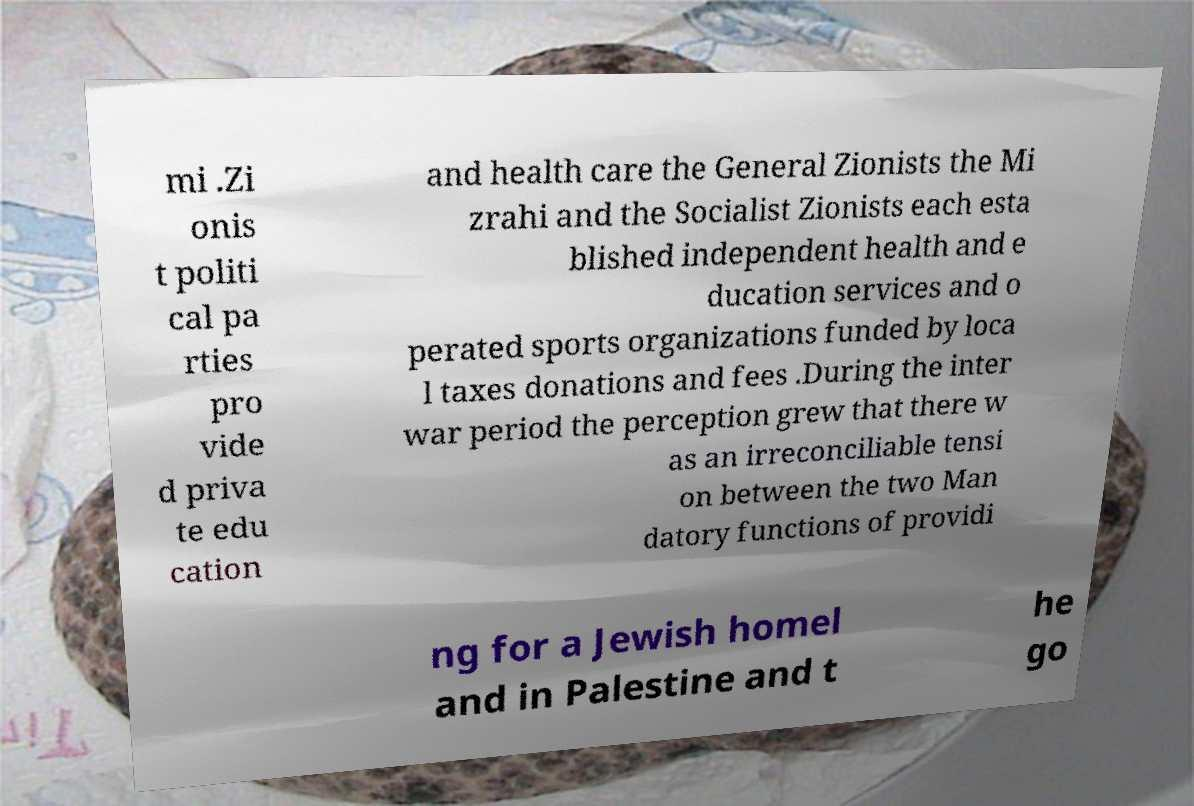Can you accurately transcribe the text from the provided image for me? mi .Zi onis t politi cal pa rties pro vide d priva te edu cation and health care the General Zionists the Mi zrahi and the Socialist Zionists each esta blished independent health and e ducation services and o perated sports organizations funded by loca l taxes donations and fees .During the inter war period the perception grew that there w as an irreconciliable tensi on between the two Man datory functions of providi ng for a Jewish homel and in Palestine and t he go 